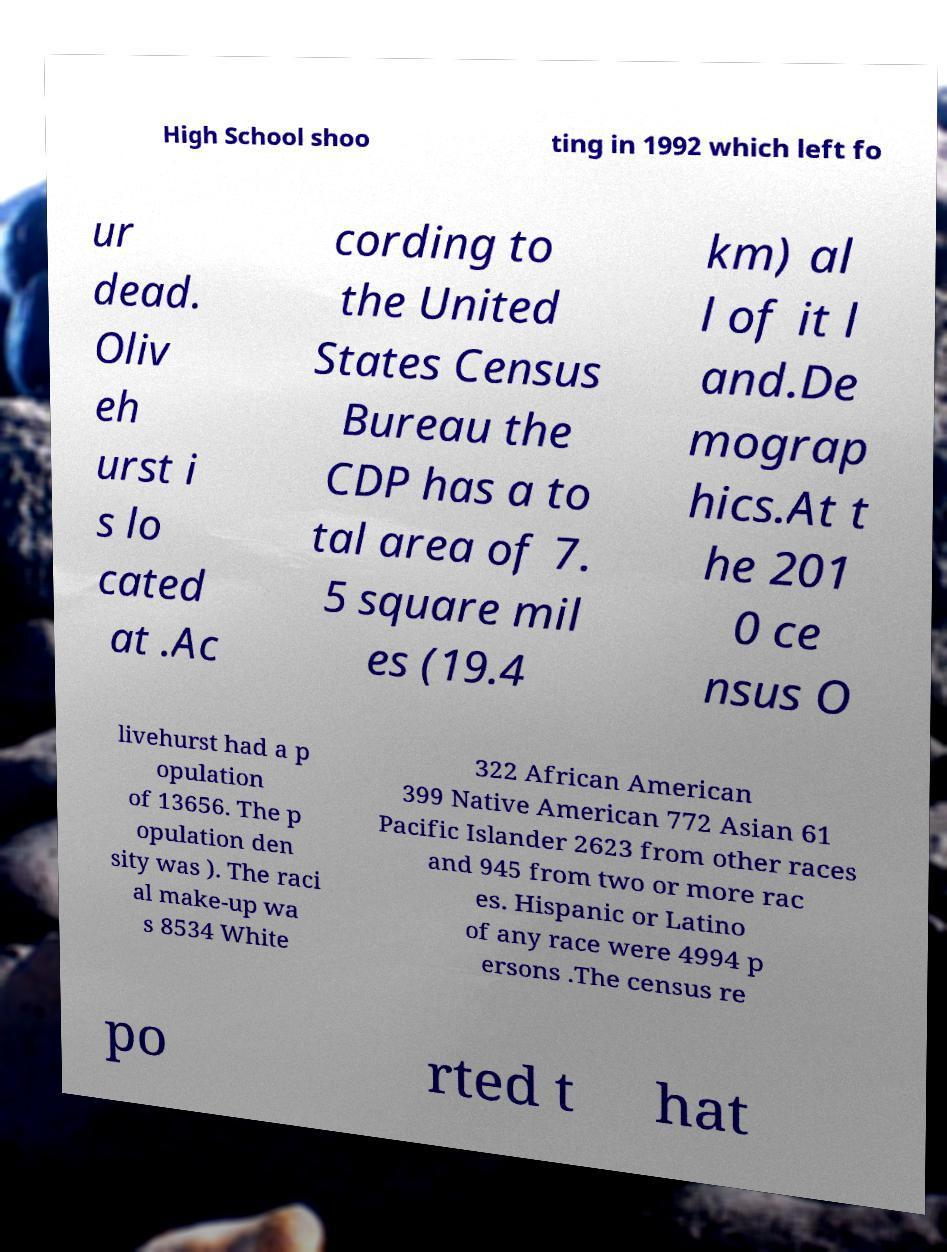Please read and relay the text visible in this image. What does it say? High School shoo ting in 1992 which left fo ur dead. Oliv eh urst i s lo cated at .Ac cording to the United States Census Bureau the CDP has a to tal area of 7. 5 square mil es (19.4 km) al l of it l and.De mograp hics.At t he 201 0 ce nsus O livehurst had a p opulation of 13656. The p opulation den sity was ). The raci al make-up wa s 8534 White 322 African American 399 Native American 772 Asian 61 Pacific Islander 2623 from other races and 945 from two or more rac es. Hispanic or Latino of any race were 4994 p ersons .The census re po rted t hat 